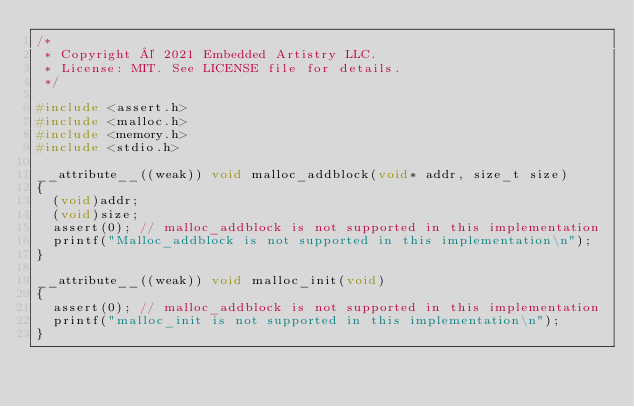Convert code to text. <code><loc_0><loc_0><loc_500><loc_500><_C_>/*
 * Copyright © 2021 Embedded Artistry LLC.
 * License: MIT. See LICENSE file for details.
 */

#include <assert.h>
#include <malloc.h>
#include <memory.h>
#include <stdio.h>

__attribute__((weak)) void malloc_addblock(void* addr, size_t size)
{
	(void)addr;
	(void)size;
	assert(0); // malloc_addblock is not supported in this implementation
	printf("Malloc_addblock is not supported in this implementation\n");
}

__attribute__((weak)) void malloc_init(void)
{
	assert(0); // malloc_addblock is not supported in this implementation
	printf("malloc_init is not supported in this implementation\n");
}
</code> 